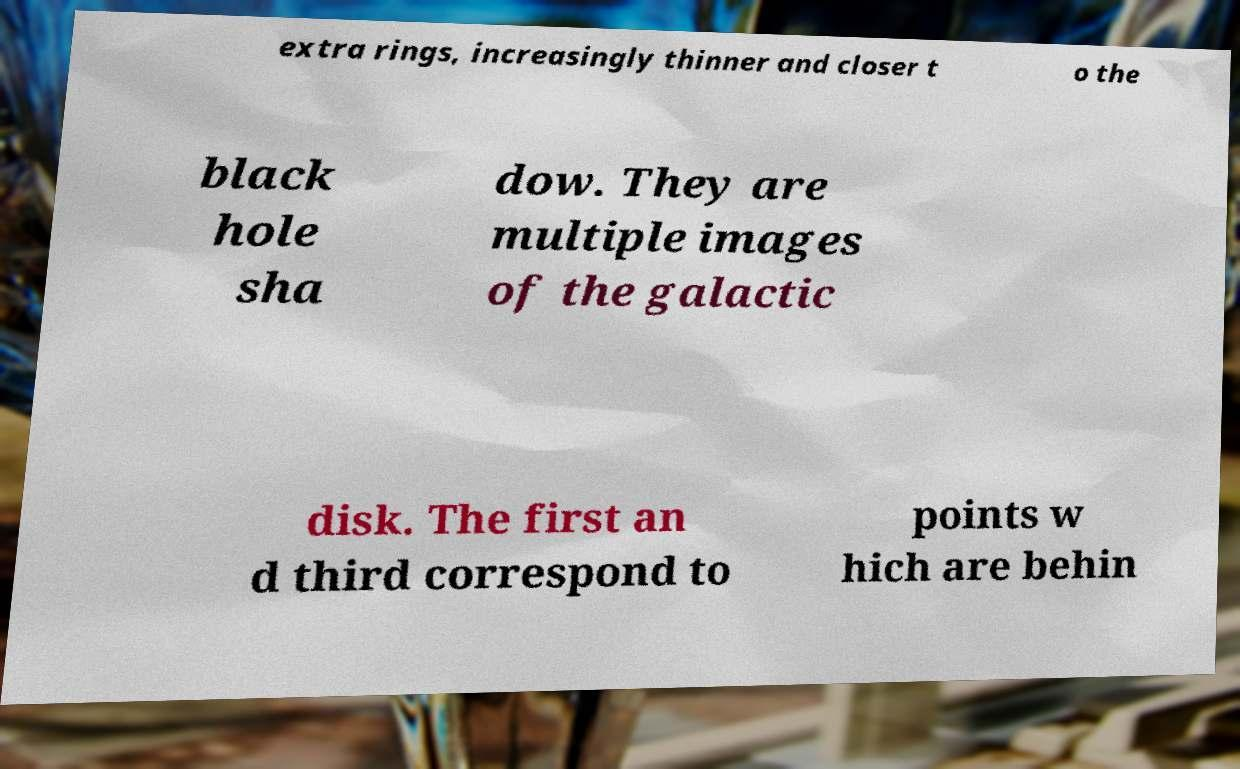Could you assist in decoding the text presented in this image and type it out clearly? extra rings, increasingly thinner and closer t o the black hole sha dow. They are multiple images of the galactic disk. The first an d third correspond to points w hich are behin 